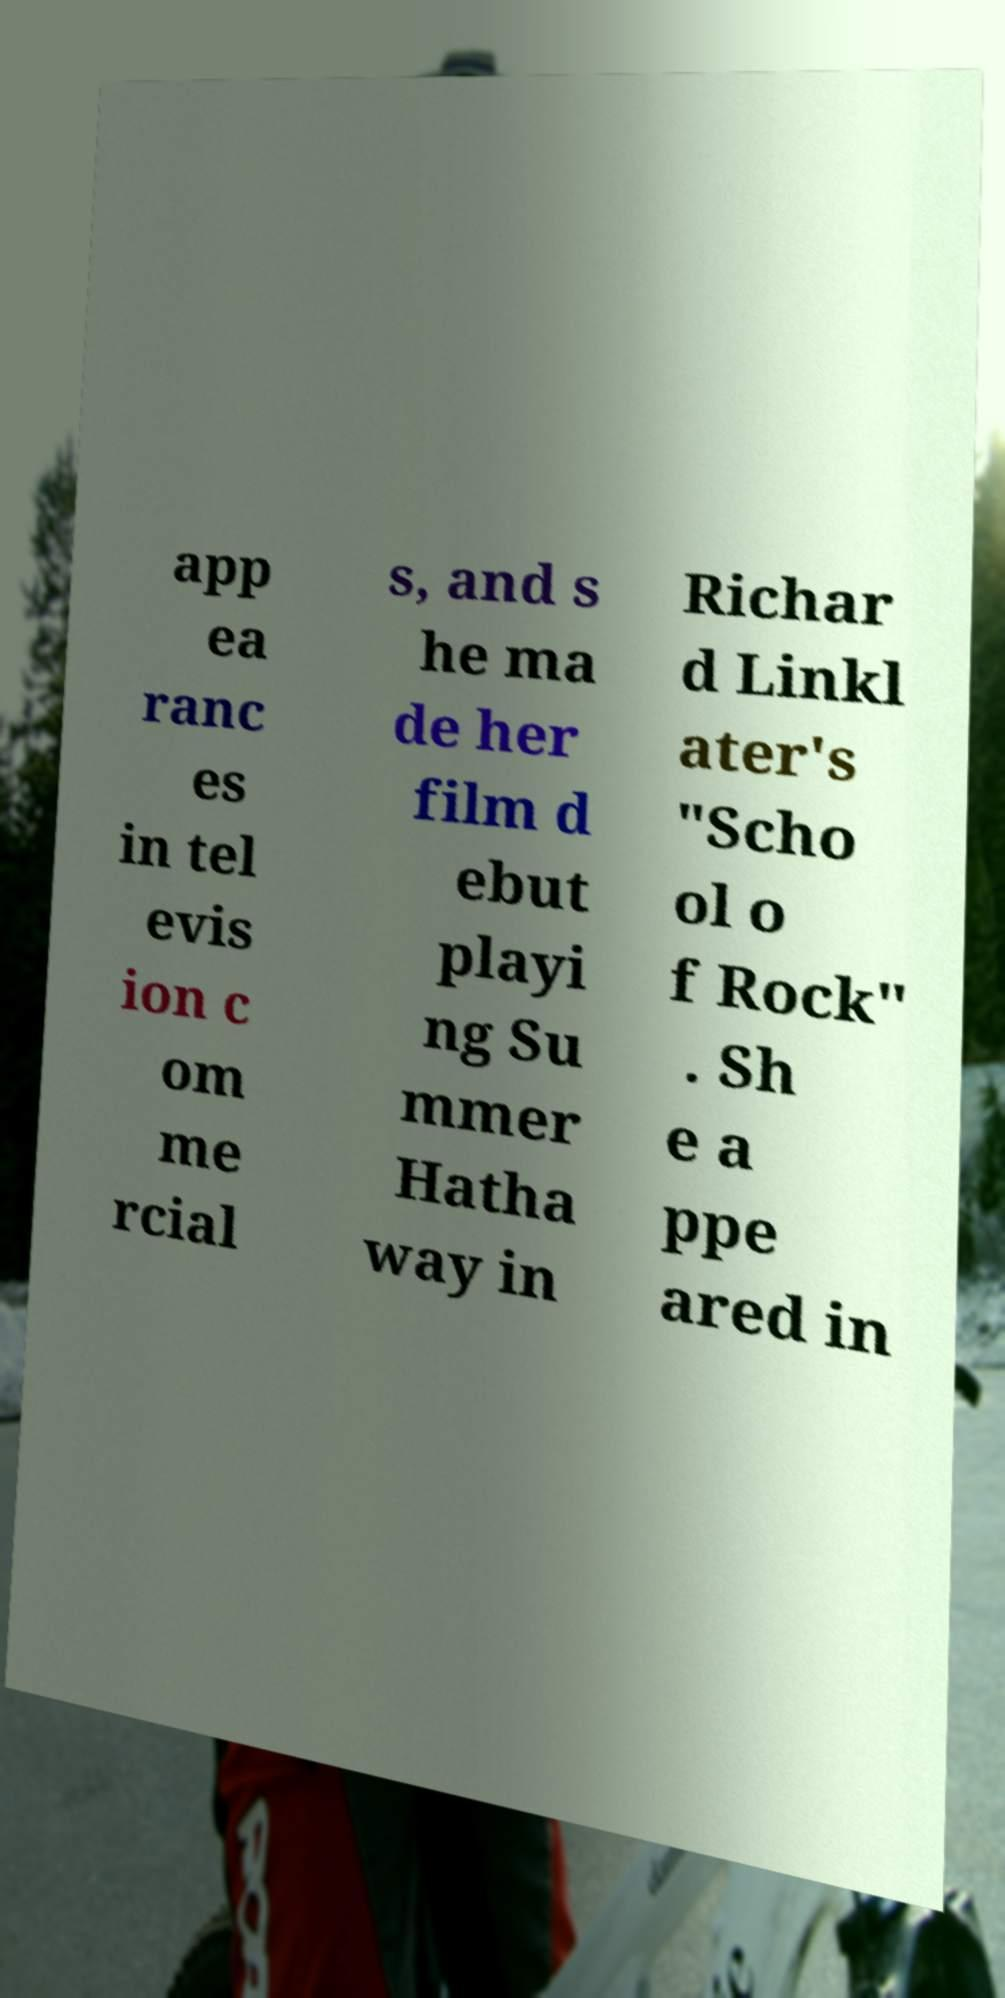Please read and relay the text visible in this image. What does it say? app ea ranc es in tel evis ion c om me rcial s, and s he ma de her film d ebut playi ng Su mmer Hatha way in Richar d Linkl ater's "Scho ol o f Rock" . Sh e a ppe ared in 